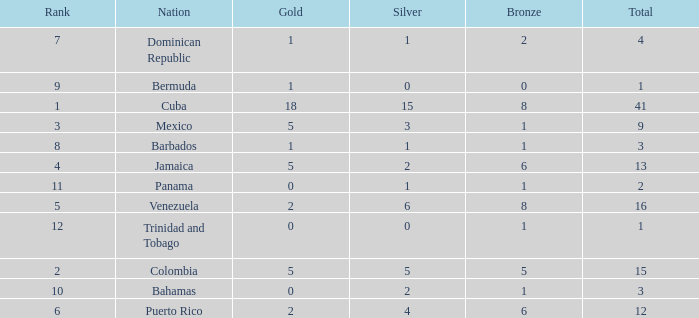Which Total is the lowest one that has a Rank smaller than 2, and a Silver smaller than 15? None. 